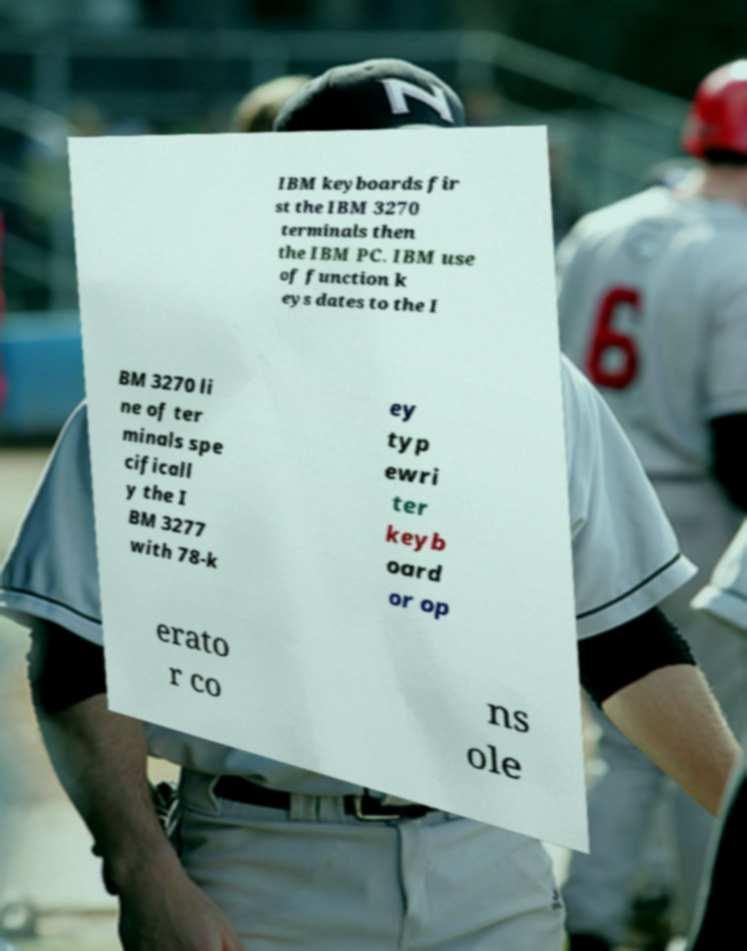Could you assist in decoding the text presented in this image and type it out clearly? IBM keyboards fir st the IBM 3270 terminals then the IBM PC. IBM use of function k eys dates to the I BM 3270 li ne of ter minals spe cificall y the I BM 3277 with 78-k ey typ ewri ter keyb oard or op erato r co ns ole 